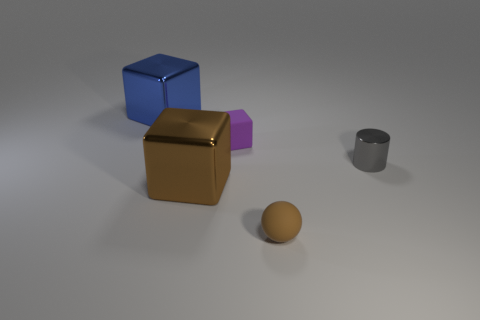What is the shape of the thing that is both on the right side of the large brown cube and behind the gray thing?
Your response must be concise. Cube. How many things are either cubes that are in front of the gray object or large cubes that are in front of the small purple cube?
Offer a very short reply. 1. How many other things are the same size as the cylinder?
Ensure brevity in your answer.  2. There is a cube that is behind the tiny purple object; is its color the same as the small shiny cylinder?
Your answer should be very brief. No. There is a object that is right of the brown cube and in front of the tiny gray metal object; how big is it?
Ensure brevity in your answer.  Small. What number of tiny things are metal cylinders or spheres?
Your response must be concise. 2. What shape is the rubber object that is in front of the tiny shiny thing?
Keep it short and to the point. Sphere. How many tiny gray metallic blocks are there?
Make the answer very short. 0. Are the blue thing and the small cube made of the same material?
Give a very brief answer. No. Are there more small things to the right of the brown metallic block than brown matte things?
Your response must be concise. Yes. 